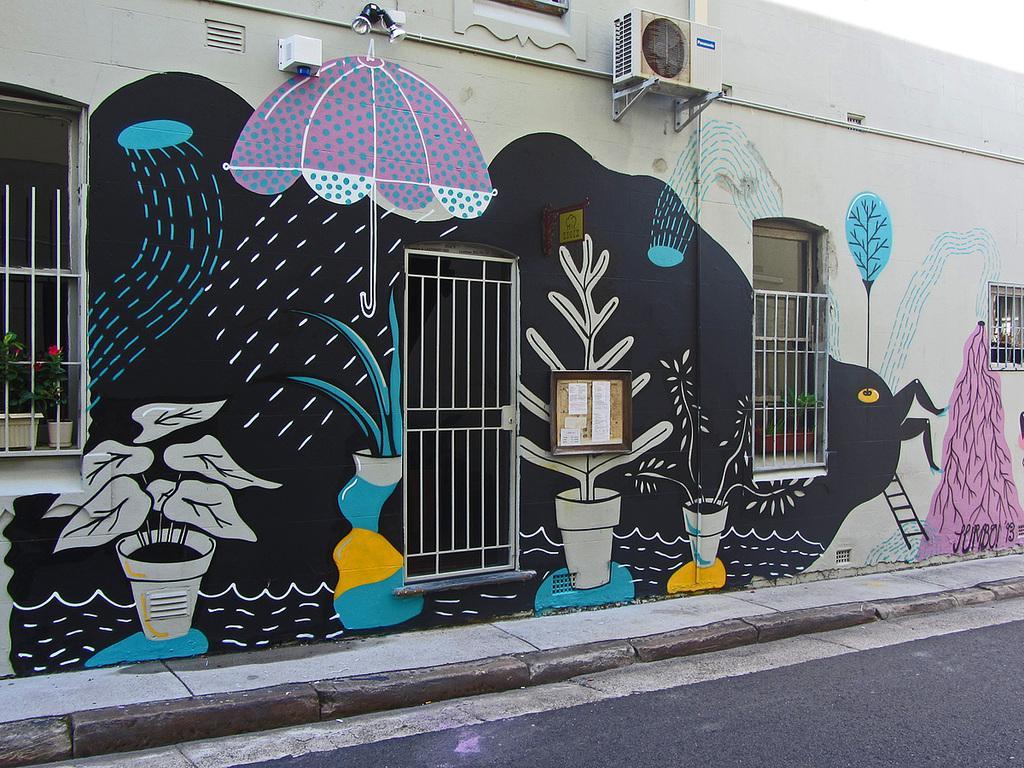Can you describe this image briefly? In the image we can see a wall and on the wall there is a painting. This is a fence, window, door, plant pot, road, skylights and a board. 